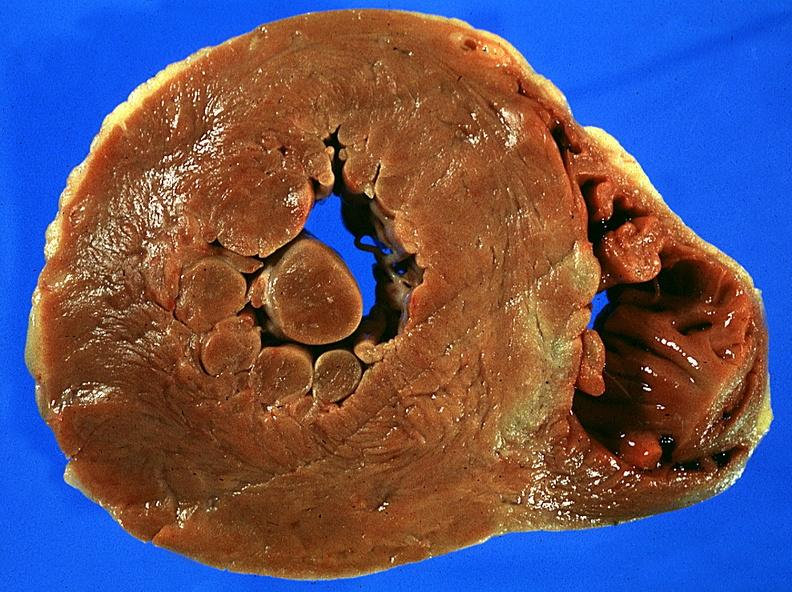where is this?
Answer the question using a single word or phrase. Heart 